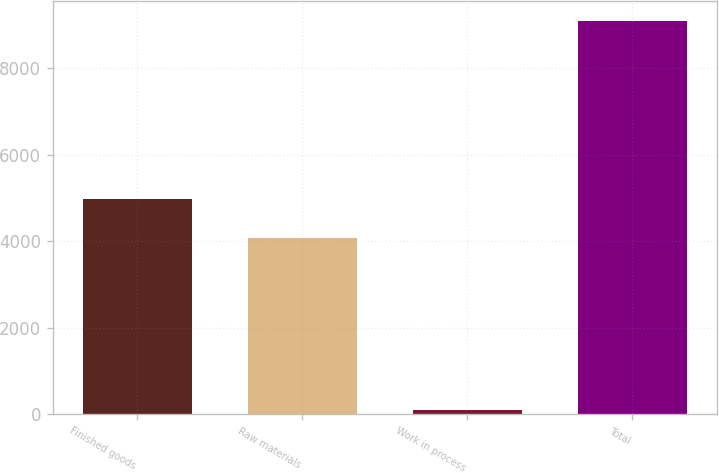<chart> <loc_0><loc_0><loc_500><loc_500><bar_chart><fcel>Finished goods<fcel>Raw materials<fcel>Work in process<fcel>Total<nl><fcel>4973.1<fcel>4073<fcel>91<fcel>9092<nl></chart> 